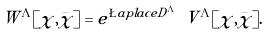Convert formula to latex. <formula><loc_0><loc_0><loc_500><loc_500>\ W ^ { \Lambda } [ \chi , \bar { \chi } ] & = e ^ { \L a p l a c e { D ^ { \Lambda } } } \, \ V ^ { \Lambda } [ \chi , \bar { \chi } ] .</formula> 